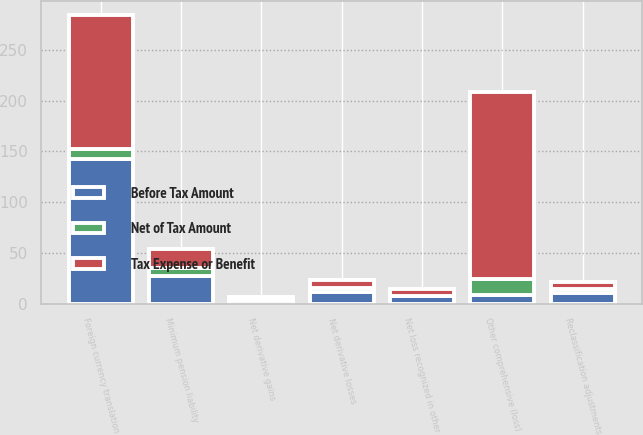Convert chart. <chart><loc_0><loc_0><loc_500><loc_500><stacked_bar_chart><ecel><fcel>Foreign currency translation<fcel>Net derivative gains<fcel>Reclassification adjustments<fcel>Net loss recognized in other<fcel>Minimum pension liability<fcel>Other comprehensive (loss)<fcel>Net derivative losses<nl><fcel>Before Tax Amount<fcel>142.2<fcel>3.4<fcel>10.6<fcel>7.2<fcel>27.1<fcel>8.2<fcel>11.6<nl><fcel>Net of Tax Amount<fcel>10.1<fcel>3.3<fcel>4.2<fcel>0.9<fcel>8.2<fcel>15.9<fcel>4.3<nl><fcel>Tax Expense or Benefit<fcel>132.1<fcel>0.1<fcel>6.4<fcel>6.3<fcel>18.9<fcel>184.4<fcel>7.3<nl></chart> 